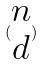Convert formula to latex. <formula><loc_0><loc_0><loc_500><loc_500>( \begin{matrix} n \\ d \end{matrix} )</formula> 